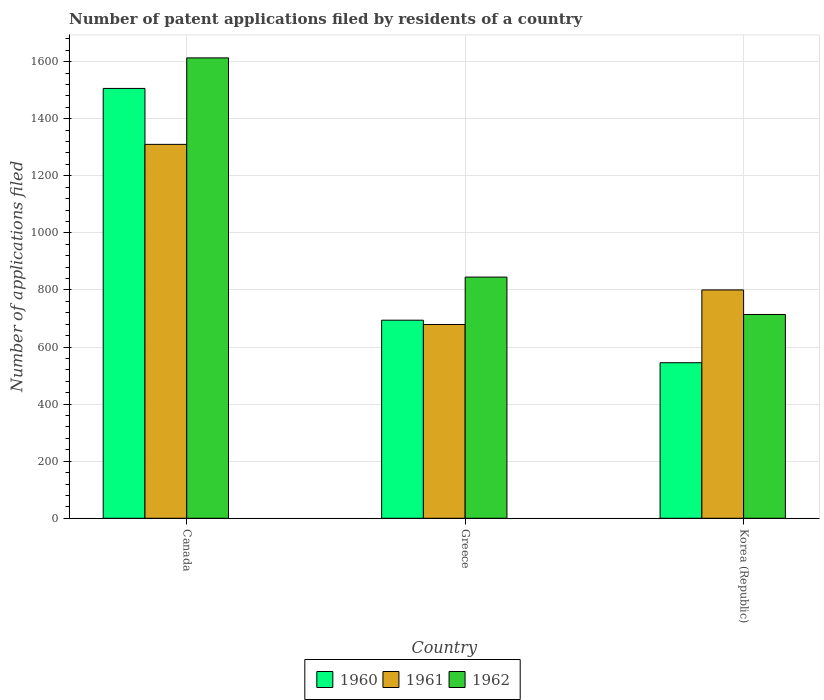How many different coloured bars are there?
Provide a succinct answer. 3. How many bars are there on the 1st tick from the left?
Offer a terse response. 3. In how many cases, is the number of bars for a given country not equal to the number of legend labels?
Your answer should be very brief. 0. What is the number of applications filed in 1961 in Korea (Republic)?
Offer a very short reply. 800. Across all countries, what is the maximum number of applications filed in 1961?
Provide a succinct answer. 1310. Across all countries, what is the minimum number of applications filed in 1960?
Keep it short and to the point. 545. In which country was the number of applications filed in 1961 maximum?
Offer a terse response. Canada. What is the total number of applications filed in 1960 in the graph?
Offer a very short reply. 2745. What is the difference between the number of applications filed in 1962 in Canada and that in Greece?
Make the answer very short. 768. What is the difference between the number of applications filed in 1962 in Greece and the number of applications filed in 1960 in Korea (Republic)?
Offer a terse response. 300. What is the average number of applications filed in 1960 per country?
Offer a terse response. 915. What is the difference between the number of applications filed of/in 1962 and number of applications filed of/in 1960 in Greece?
Ensure brevity in your answer.  151. What is the ratio of the number of applications filed in 1960 in Greece to that in Korea (Republic)?
Provide a succinct answer. 1.27. What is the difference between the highest and the second highest number of applications filed in 1962?
Provide a succinct answer. -131. What is the difference between the highest and the lowest number of applications filed in 1962?
Offer a terse response. 899. In how many countries, is the number of applications filed in 1960 greater than the average number of applications filed in 1960 taken over all countries?
Provide a short and direct response. 1. What does the 2nd bar from the left in Greece represents?
Provide a short and direct response. 1961. Is it the case that in every country, the sum of the number of applications filed in 1962 and number of applications filed in 1961 is greater than the number of applications filed in 1960?
Provide a short and direct response. Yes. What is the difference between two consecutive major ticks on the Y-axis?
Offer a very short reply. 200. Does the graph contain any zero values?
Your answer should be very brief. No. Does the graph contain grids?
Keep it short and to the point. Yes. How many legend labels are there?
Keep it short and to the point. 3. What is the title of the graph?
Your answer should be compact. Number of patent applications filed by residents of a country. What is the label or title of the Y-axis?
Ensure brevity in your answer.  Number of applications filed. What is the Number of applications filed of 1960 in Canada?
Keep it short and to the point. 1506. What is the Number of applications filed in 1961 in Canada?
Offer a very short reply. 1310. What is the Number of applications filed in 1962 in Canada?
Make the answer very short. 1613. What is the Number of applications filed in 1960 in Greece?
Offer a very short reply. 694. What is the Number of applications filed in 1961 in Greece?
Give a very brief answer. 679. What is the Number of applications filed in 1962 in Greece?
Give a very brief answer. 845. What is the Number of applications filed in 1960 in Korea (Republic)?
Ensure brevity in your answer.  545. What is the Number of applications filed of 1961 in Korea (Republic)?
Provide a short and direct response. 800. What is the Number of applications filed of 1962 in Korea (Republic)?
Your response must be concise. 714. Across all countries, what is the maximum Number of applications filed of 1960?
Provide a succinct answer. 1506. Across all countries, what is the maximum Number of applications filed of 1961?
Your response must be concise. 1310. Across all countries, what is the maximum Number of applications filed of 1962?
Provide a succinct answer. 1613. Across all countries, what is the minimum Number of applications filed of 1960?
Provide a succinct answer. 545. Across all countries, what is the minimum Number of applications filed of 1961?
Keep it short and to the point. 679. Across all countries, what is the minimum Number of applications filed of 1962?
Provide a short and direct response. 714. What is the total Number of applications filed in 1960 in the graph?
Give a very brief answer. 2745. What is the total Number of applications filed in 1961 in the graph?
Offer a terse response. 2789. What is the total Number of applications filed of 1962 in the graph?
Offer a terse response. 3172. What is the difference between the Number of applications filed of 1960 in Canada and that in Greece?
Make the answer very short. 812. What is the difference between the Number of applications filed of 1961 in Canada and that in Greece?
Keep it short and to the point. 631. What is the difference between the Number of applications filed in 1962 in Canada and that in Greece?
Provide a succinct answer. 768. What is the difference between the Number of applications filed in 1960 in Canada and that in Korea (Republic)?
Give a very brief answer. 961. What is the difference between the Number of applications filed in 1961 in Canada and that in Korea (Republic)?
Give a very brief answer. 510. What is the difference between the Number of applications filed in 1962 in Canada and that in Korea (Republic)?
Provide a succinct answer. 899. What is the difference between the Number of applications filed of 1960 in Greece and that in Korea (Republic)?
Make the answer very short. 149. What is the difference between the Number of applications filed of 1961 in Greece and that in Korea (Republic)?
Give a very brief answer. -121. What is the difference between the Number of applications filed in 1962 in Greece and that in Korea (Republic)?
Keep it short and to the point. 131. What is the difference between the Number of applications filed of 1960 in Canada and the Number of applications filed of 1961 in Greece?
Your answer should be very brief. 827. What is the difference between the Number of applications filed in 1960 in Canada and the Number of applications filed in 1962 in Greece?
Ensure brevity in your answer.  661. What is the difference between the Number of applications filed in 1961 in Canada and the Number of applications filed in 1962 in Greece?
Provide a short and direct response. 465. What is the difference between the Number of applications filed of 1960 in Canada and the Number of applications filed of 1961 in Korea (Republic)?
Make the answer very short. 706. What is the difference between the Number of applications filed of 1960 in Canada and the Number of applications filed of 1962 in Korea (Republic)?
Provide a succinct answer. 792. What is the difference between the Number of applications filed of 1961 in Canada and the Number of applications filed of 1962 in Korea (Republic)?
Your answer should be very brief. 596. What is the difference between the Number of applications filed in 1960 in Greece and the Number of applications filed in 1961 in Korea (Republic)?
Give a very brief answer. -106. What is the difference between the Number of applications filed in 1961 in Greece and the Number of applications filed in 1962 in Korea (Republic)?
Your answer should be compact. -35. What is the average Number of applications filed of 1960 per country?
Give a very brief answer. 915. What is the average Number of applications filed of 1961 per country?
Keep it short and to the point. 929.67. What is the average Number of applications filed of 1962 per country?
Make the answer very short. 1057.33. What is the difference between the Number of applications filed in 1960 and Number of applications filed in 1961 in Canada?
Make the answer very short. 196. What is the difference between the Number of applications filed of 1960 and Number of applications filed of 1962 in Canada?
Give a very brief answer. -107. What is the difference between the Number of applications filed in 1961 and Number of applications filed in 1962 in Canada?
Give a very brief answer. -303. What is the difference between the Number of applications filed of 1960 and Number of applications filed of 1962 in Greece?
Keep it short and to the point. -151. What is the difference between the Number of applications filed in 1961 and Number of applications filed in 1962 in Greece?
Provide a short and direct response. -166. What is the difference between the Number of applications filed of 1960 and Number of applications filed of 1961 in Korea (Republic)?
Provide a short and direct response. -255. What is the difference between the Number of applications filed of 1960 and Number of applications filed of 1962 in Korea (Republic)?
Keep it short and to the point. -169. What is the difference between the Number of applications filed of 1961 and Number of applications filed of 1962 in Korea (Republic)?
Provide a succinct answer. 86. What is the ratio of the Number of applications filed in 1960 in Canada to that in Greece?
Ensure brevity in your answer.  2.17. What is the ratio of the Number of applications filed in 1961 in Canada to that in Greece?
Your answer should be compact. 1.93. What is the ratio of the Number of applications filed of 1962 in Canada to that in Greece?
Ensure brevity in your answer.  1.91. What is the ratio of the Number of applications filed of 1960 in Canada to that in Korea (Republic)?
Offer a terse response. 2.76. What is the ratio of the Number of applications filed of 1961 in Canada to that in Korea (Republic)?
Offer a very short reply. 1.64. What is the ratio of the Number of applications filed of 1962 in Canada to that in Korea (Republic)?
Make the answer very short. 2.26. What is the ratio of the Number of applications filed of 1960 in Greece to that in Korea (Republic)?
Your answer should be compact. 1.27. What is the ratio of the Number of applications filed in 1961 in Greece to that in Korea (Republic)?
Offer a very short reply. 0.85. What is the ratio of the Number of applications filed of 1962 in Greece to that in Korea (Republic)?
Give a very brief answer. 1.18. What is the difference between the highest and the second highest Number of applications filed in 1960?
Make the answer very short. 812. What is the difference between the highest and the second highest Number of applications filed of 1961?
Your answer should be very brief. 510. What is the difference between the highest and the second highest Number of applications filed of 1962?
Give a very brief answer. 768. What is the difference between the highest and the lowest Number of applications filed of 1960?
Give a very brief answer. 961. What is the difference between the highest and the lowest Number of applications filed of 1961?
Offer a very short reply. 631. What is the difference between the highest and the lowest Number of applications filed of 1962?
Give a very brief answer. 899. 